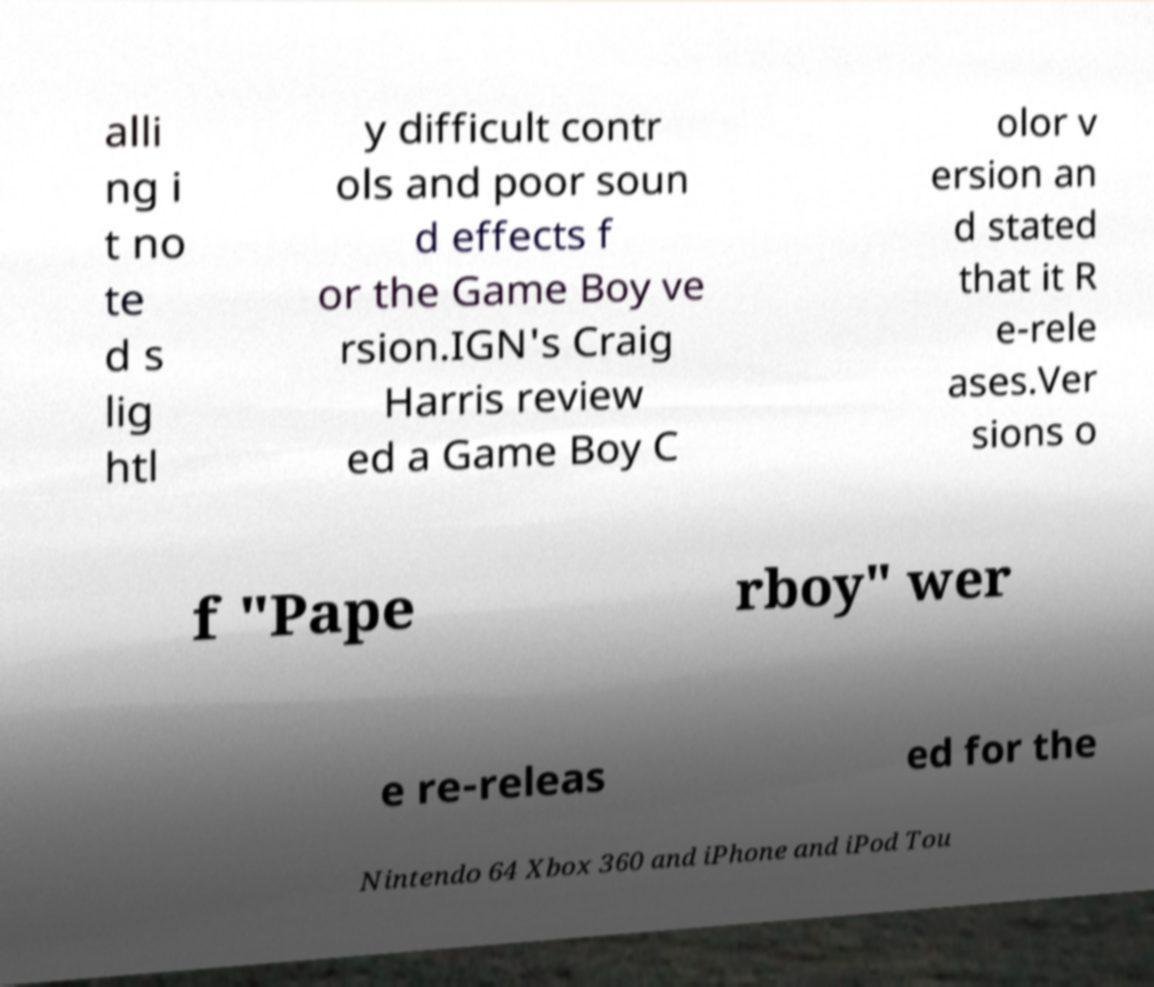For documentation purposes, I need the text within this image transcribed. Could you provide that? alli ng i t no te d s lig htl y difficult contr ols and poor soun d effects f or the Game Boy ve rsion.IGN's Craig Harris review ed a Game Boy C olor v ersion an d stated that it R e-rele ases.Ver sions o f "Pape rboy" wer e re-releas ed for the Nintendo 64 Xbox 360 and iPhone and iPod Tou 